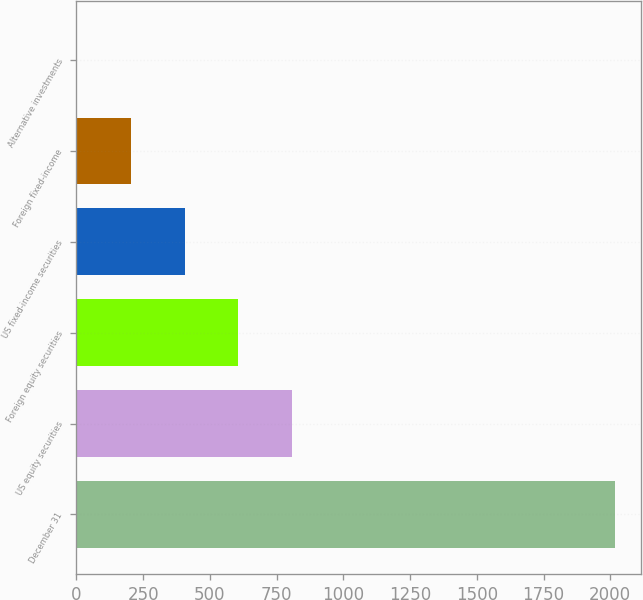Convert chart to OTSL. <chart><loc_0><loc_0><loc_500><loc_500><bar_chart><fcel>December 31<fcel>US equity securities<fcel>Foreign equity securities<fcel>US fixed-income securities<fcel>Foreign fixed-income<fcel>Alternative investments<nl><fcel>2016<fcel>808.2<fcel>606.9<fcel>405.6<fcel>204.3<fcel>3<nl></chart> 